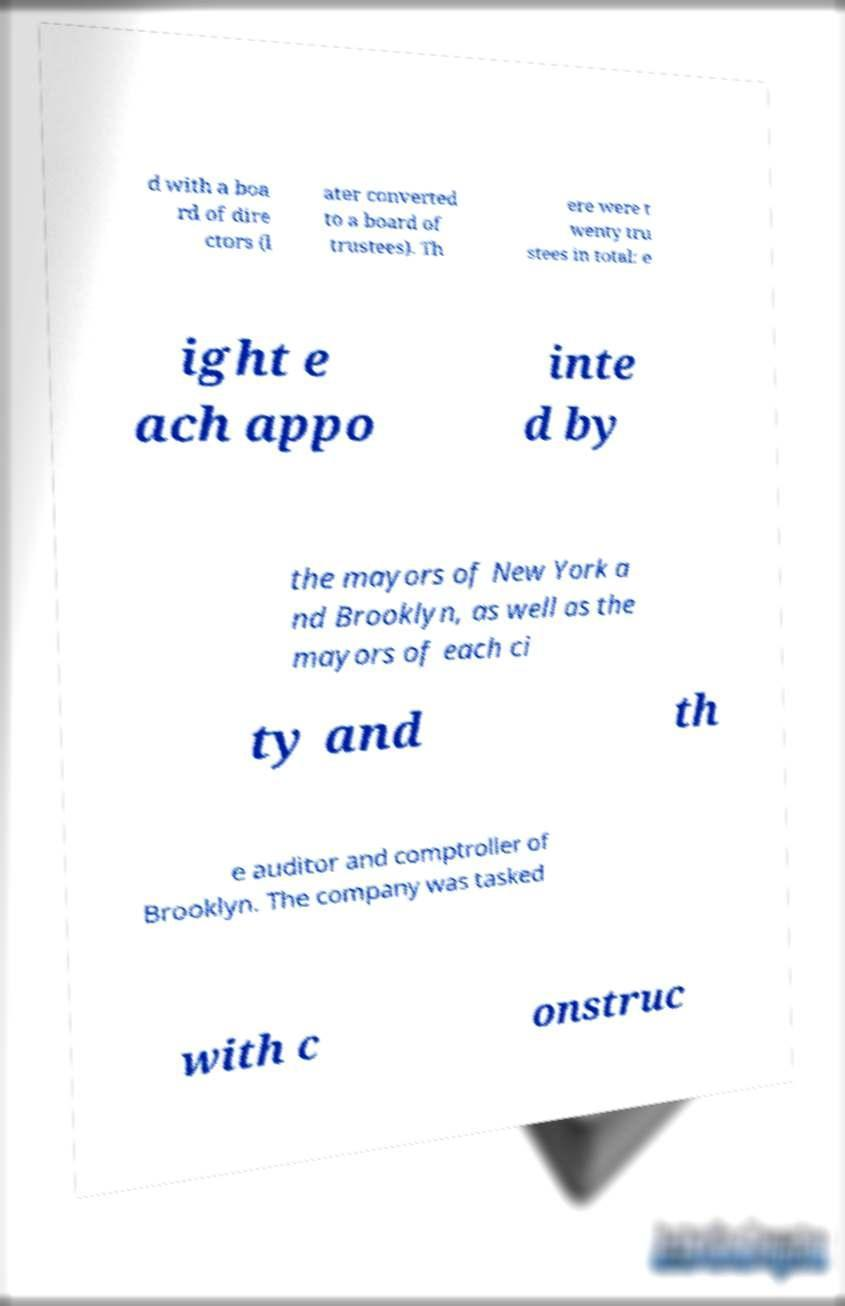Can you accurately transcribe the text from the provided image for me? d with a boa rd of dire ctors (l ater converted to a board of trustees). Th ere were t wenty tru stees in total: e ight e ach appo inte d by the mayors of New York a nd Brooklyn, as well as the mayors of each ci ty and th e auditor and comptroller of Brooklyn. The company was tasked with c onstruc 